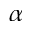Convert formula to latex. <formula><loc_0><loc_0><loc_500><loc_500>\alpha</formula> 